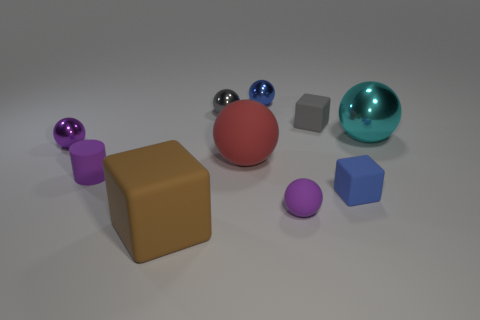There is another small ball that is the same color as the small rubber ball; what material is it?
Your answer should be very brief. Metal. What is the shape of the rubber object that is the same color as the tiny rubber ball?
Your answer should be very brief. Cylinder. The cylinder that is the same color as the small matte sphere is what size?
Keep it short and to the point. Small. How many other things are there of the same shape as the blue metallic thing?
Provide a short and direct response. 5. There is a small shiny object that is in front of the cyan object; is it the same shape as the blue thing that is behind the big shiny ball?
Provide a succinct answer. Yes. Is the number of blue shiny spheres left of the purple rubber ball the same as the number of shiny spheres in front of the small purple cylinder?
Provide a short and direct response. No. What shape is the purple object on the left side of the purple rubber object to the left of the big object in front of the small purple matte cylinder?
Give a very brief answer. Sphere. Does the large brown object to the right of the small purple cylinder have the same material as the small block in front of the cyan thing?
Offer a very short reply. Yes. There is a small blue thing on the right side of the blue ball; what shape is it?
Provide a short and direct response. Cube. Are there fewer purple cylinders than small yellow cubes?
Provide a short and direct response. No. 